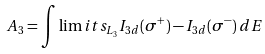<formula> <loc_0><loc_0><loc_500><loc_500>A _ { 3 } = \int \lim i t s _ { L _ { 3 } } I _ { 3 d } ( \sigma ^ { + } ) - I _ { 3 d } ( \sigma ^ { - } ) \, d E</formula> 